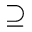<formula> <loc_0><loc_0><loc_500><loc_500>\supseteq</formula> 